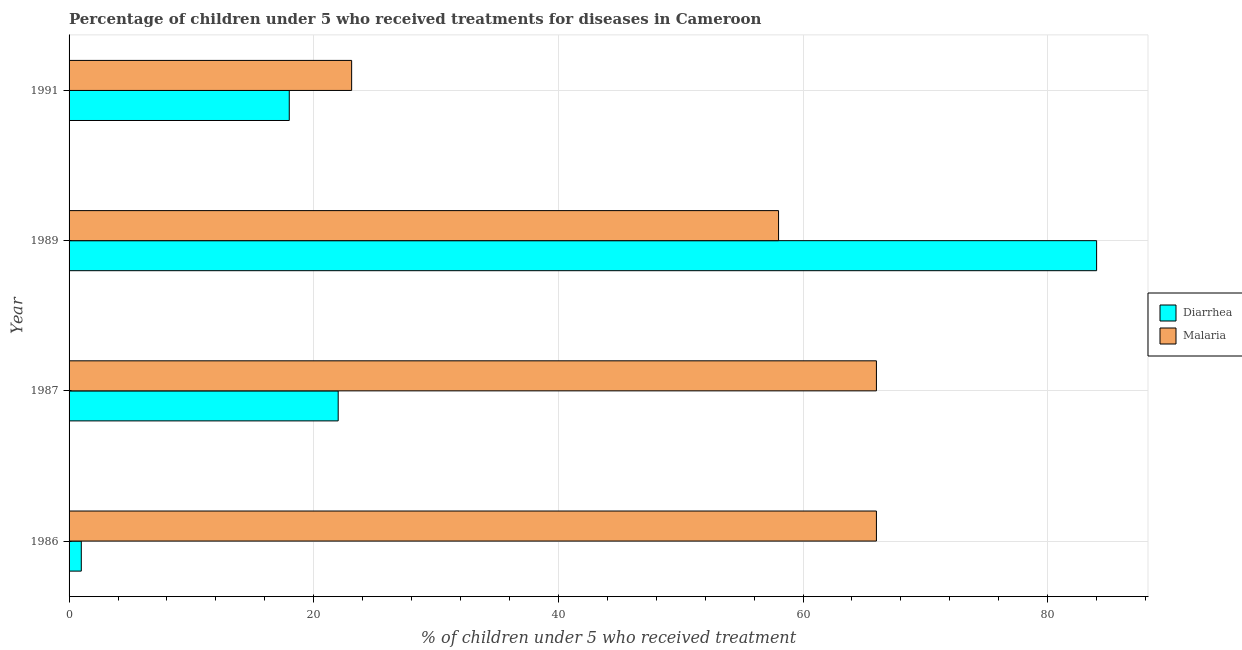How many bars are there on the 2nd tick from the top?
Ensure brevity in your answer.  2. How many bars are there on the 4th tick from the bottom?
Ensure brevity in your answer.  2. What is the label of the 1st group of bars from the top?
Your answer should be very brief. 1991. What is the percentage of children who received treatment for malaria in 1991?
Make the answer very short. 23.1. Across all years, what is the minimum percentage of children who received treatment for diarrhoea?
Offer a very short reply. 1. In which year was the percentage of children who received treatment for diarrhoea maximum?
Provide a short and direct response. 1989. In which year was the percentage of children who received treatment for diarrhoea minimum?
Your response must be concise. 1986. What is the total percentage of children who received treatment for malaria in the graph?
Provide a succinct answer. 213.1. What is the difference between the percentage of children who received treatment for diarrhoea in 1987 and that in 1991?
Offer a terse response. 4. What is the difference between the percentage of children who received treatment for malaria in 1987 and the percentage of children who received treatment for diarrhoea in 1991?
Your response must be concise. 48. What is the average percentage of children who received treatment for diarrhoea per year?
Provide a short and direct response. 31.25. In the year 1991, what is the difference between the percentage of children who received treatment for diarrhoea and percentage of children who received treatment for malaria?
Offer a very short reply. -5.1. In how many years, is the percentage of children who received treatment for diarrhoea greater than 32 %?
Provide a short and direct response. 1. What is the ratio of the percentage of children who received treatment for diarrhoea in 1989 to that in 1991?
Provide a short and direct response. 4.67. Is the difference between the percentage of children who received treatment for malaria in 1987 and 1989 greater than the difference between the percentage of children who received treatment for diarrhoea in 1987 and 1989?
Your response must be concise. Yes. What is the difference between the highest and the lowest percentage of children who received treatment for diarrhoea?
Provide a short and direct response. 83. In how many years, is the percentage of children who received treatment for malaria greater than the average percentage of children who received treatment for malaria taken over all years?
Make the answer very short. 3. What does the 2nd bar from the top in 1991 represents?
Ensure brevity in your answer.  Diarrhea. What does the 2nd bar from the bottom in 1987 represents?
Your answer should be compact. Malaria. How many bars are there?
Ensure brevity in your answer.  8. Are all the bars in the graph horizontal?
Provide a short and direct response. Yes. Are the values on the major ticks of X-axis written in scientific E-notation?
Ensure brevity in your answer.  No. Does the graph contain any zero values?
Provide a short and direct response. No. Does the graph contain grids?
Your answer should be very brief. Yes. Where does the legend appear in the graph?
Provide a succinct answer. Center right. What is the title of the graph?
Provide a short and direct response. Percentage of children under 5 who received treatments for diseases in Cameroon. Does "Export" appear as one of the legend labels in the graph?
Provide a succinct answer. No. What is the label or title of the X-axis?
Make the answer very short. % of children under 5 who received treatment. What is the label or title of the Y-axis?
Provide a succinct answer. Year. What is the % of children under 5 who received treatment in Diarrhea in 1986?
Give a very brief answer. 1. What is the % of children under 5 who received treatment of Malaria in 1986?
Give a very brief answer. 66. What is the % of children under 5 who received treatment in Malaria in 1987?
Ensure brevity in your answer.  66. What is the % of children under 5 who received treatment in Diarrhea in 1989?
Give a very brief answer. 84. What is the % of children under 5 who received treatment in Malaria in 1991?
Your answer should be very brief. 23.1. Across all years, what is the maximum % of children under 5 who received treatment of Diarrhea?
Offer a terse response. 84. Across all years, what is the maximum % of children under 5 who received treatment in Malaria?
Your answer should be very brief. 66. Across all years, what is the minimum % of children under 5 who received treatment in Malaria?
Your answer should be compact. 23.1. What is the total % of children under 5 who received treatment in Diarrhea in the graph?
Offer a very short reply. 125. What is the total % of children under 5 who received treatment of Malaria in the graph?
Your answer should be compact. 213.1. What is the difference between the % of children under 5 who received treatment in Diarrhea in 1986 and that in 1987?
Offer a terse response. -21. What is the difference between the % of children under 5 who received treatment in Diarrhea in 1986 and that in 1989?
Your response must be concise. -83. What is the difference between the % of children under 5 who received treatment in Malaria in 1986 and that in 1989?
Your response must be concise. 8. What is the difference between the % of children under 5 who received treatment of Diarrhea in 1986 and that in 1991?
Your answer should be very brief. -17. What is the difference between the % of children under 5 who received treatment of Malaria in 1986 and that in 1991?
Provide a succinct answer. 42.9. What is the difference between the % of children under 5 who received treatment in Diarrhea in 1987 and that in 1989?
Give a very brief answer. -62. What is the difference between the % of children under 5 who received treatment in Malaria in 1987 and that in 1989?
Keep it short and to the point. 8. What is the difference between the % of children under 5 who received treatment of Malaria in 1987 and that in 1991?
Keep it short and to the point. 42.9. What is the difference between the % of children under 5 who received treatment in Malaria in 1989 and that in 1991?
Offer a terse response. 34.9. What is the difference between the % of children under 5 who received treatment of Diarrhea in 1986 and the % of children under 5 who received treatment of Malaria in 1987?
Your response must be concise. -65. What is the difference between the % of children under 5 who received treatment of Diarrhea in 1986 and the % of children under 5 who received treatment of Malaria in 1989?
Your answer should be very brief. -57. What is the difference between the % of children under 5 who received treatment of Diarrhea in 1986 and the % of children under 5 who received treatment of Malaria in 1991?
Provide a short and direct response. -22.1. What is the difference between the % of children under 5 who received treatment of Diarrhea in 1987 and the % of children under 5 who received treatment of Malaria in 1989?
Your answer should be very brief. -36. What is the difference between the % of children under 5 who received treatment of Diarrhea in 1987 and the % of children under 5 who received treatment of Malaria in 1991?
Give a very brief answer. -1.1. What is the difference between the % of children under 5 who received treatment in Diarrhea in 1989 and the % of children under 5 who received treatment in Malaria in 1991?
Offer a terse response. 60.9. What is the average % of children under 5 who received treatment of Diarrhea per year?
Provide a short and direct response. 31.25. What is the average % of children under 5 who received treatment of Malaria per year?
Ensure brevity in your answer.  53.27. In the year 1986, what is the difference between the % of children under 5 who received treatment of Diarrhea and % of children under 5 who received treatment of Malaria?
Provide a short and direct response. -65. In the year 1987, what is the difference between the % of children under 5 who received treatment of Diarrhea and % of children under 5 who received treatment of Malaria?
Provide a short and direct response. -44. In the year 1989, what is the difference between the % of children under 5 who received treatment of Diarrhea and % of children under 5 who received treatment of Malaria?
Your answer should be compact. 26. In the year 1991, what is the difference between the % of children under 5 who received treatment of Diarrhea and % of children under 5 who received treatment of Malaria?
Ensure brevity in your answer.  -5.1. What is the ratio of the % of children under 5 who received treatment in Diarrhea in 1986 to that in 1987?
Give a very brief answer. 0.05. What is the ratio of the % of children under 5 who received treatment of Malaria in 1986 to that in 1987?
Provide a short and direct response. 1. What is the ratio of the % of children under 5 who received treatment in Diarrhea in 1986 to that in 1989?
Ensure brevity in your answer.  0.01. What is the ratio of the % of children under 5 who received treatment of Malaria in 1986 to that in 1989?
Give a very brief answer. 1.14. What is the ratio of the % of children under 5 who received treatment in Diarrhea in 1986 to that in 1991?
Provide a succinct answer. 0.06. What is the ratio of the % of children under 5 who received treatment in Malaria in 1986 to that in 1991?
Offer a very short reply. 2.86. What is the ratio of the % of children under 5 who received treatment of Diarrhea in 1987 to that in 1989?
Your answer should be very brief. 0.26. What is the ratio of the % of children under 5 who received treatment of Malaria in 1987 to that in 1989?
Your answer should be compact. 1.14. What is the ratio of the % of children under 5 who received treatment in Diarrhea in 1987 to that in 1991?
Your answer should be very brief. 1.22. What is the ratio of the % of children under 5 who received treatment in Malaria in 1987 to that in 1991?
Provide a succinct answer. 2.86. What is the ratio of the % of children under 5 who received treatment of Diarrhea in 1989 to that in 1991?
Provide a short and direct response. 4.67. What is the ratio of the % of children under 5 who received treatment in Malaria in 1989 to that in 1991?
Provide a succinct answer. 2.51. What is the difference between the highest and the second highest % of children under 5 who received treatment of Diarrhea?
Provide a short and direct response. 62. What is the difference between the highest and the second highest % of children under 5 who received treatment in Malaria?
Your answer should be compact. 0. What is the difference between the highest and the lowest % of children under 5 who received treatment in Malaria?
Your answer should be compact. 42.9. 